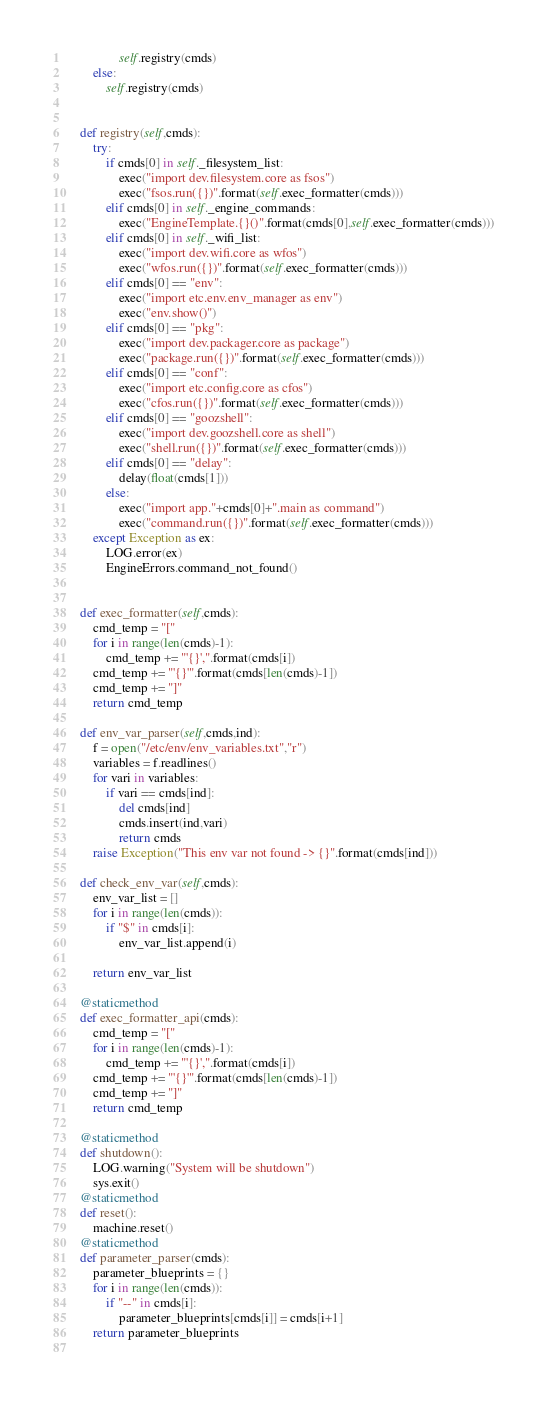<code> <loc_0><loc_0><loc_500><loc_500><_Python_>                self.registry(cmds)
        else:
            self.registry(cmds)


    def registry(self,cmds):
        try:
            if cmds[0] in self._filesystem_list:
                exec("import dev.filesystem.core as fsos")
                exec("fsos.run({})".format(self.exec_formatter(cmds)))
            elif cmds[0] in self._engine_commands:
                exec("EngineTemplate.{}()".format(cmds[0],self.exec_formatter(cmds)))
            elif cmds[0] in self._wifi_list:
                exec("import dev.wifi.core as wfos")
                exec("wfos.run({})".format(self.exec_formatter(cmds)))
            elif cmds[0] == "env":
                exec("import etc.env.env_manager as env")
                exec("env.show()")
            elif cmds[0] == "pkg":
                exec("import dev.packager.core as package")
                exec("package.run({})".format(self.exec_formatter(cmds)))
            elif cmds[0] == "conf":
                exec("import etc.config.core as cfos")
                exec("cfos.run({})".format(self.exec_formatter(cmds)))
            elif cmds[0] == "goozshell":
                exec("import dev.goozshell.core as shell")
                exec("shell.run({})".format(self.exec_formatter(cmds)))
            elif cmds[0] == "delay":
                delay(float(cmds[1]))
            else:
                exec("import app."+cmds[0]+".main as command")
                exec("command.run({})".format(self.exec_formatter(cmds)))
        except Exception as ex:
            LOG.error(ex)
            EngineErrors.command_not_found()


    def exec_formatter(self,cmds):
        cmd_temp = "["
        for i in range(len(cmds)-1):
            cmd_temp += "'{}',".format(cmds[i])
        cmd_temp += "'{}'".format(cmds[len(cmds)-1])
        cmd_temp += "]"
        return cmd_temp
    
    def env_var_parser(self,cmds,ind):
        f = open("/etc/env/env_variables.txt","r")
        variables = f.readlines()
        for vari in variables:
            if vari == cmds[ind]:
                del cmds[ind]
                cmds.insert(ind,vari)
                return cmds
        raise Exception("This env var not found -> {}".format(cmds[ind]))
    
    def check_env_var(self,cmds):
        env_var_list = []
        for i in range(len(cmds)):
            if "$" in cmds[i]:
                env_var_list.append(i)

        return env_var_list

    @staticmethod
    def exec_formatter_api(cmds):
        cmd_temp = "["
        for i in range(len(cmds)-1):
            cmd_temp += "'{}',".format(cmds[i])
        cmd_temp += "'{}'".format(cmds[len(cmds)-1])
        cmd_temp += "]"
        return cmd_temp

    @staticmethod
    def shutdown():
        LOG.warning("System will be shutdown")
        sys.exit()
    @staticmethod
    def reset():
        machine.reset()
    @staticmethod
    def parameter_parser(cmds):
        parameter_blueprints = {}
        for i in range(len(cmds)):
            if "--" in cmds[i]:
                parameter_blueprints[cmds[i]] = cmds[i+1]
        return parameter_blueprints
                </code> 